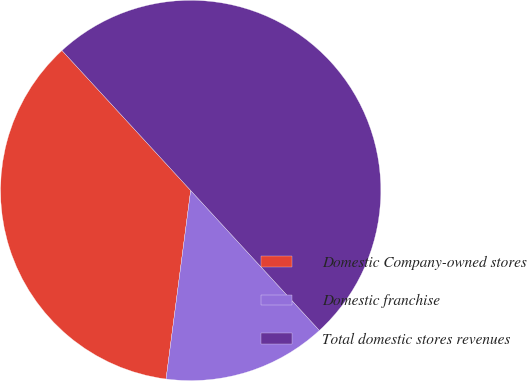Convert chart to OTSL. <chart><loc_0><loc_0><loc_500><loc_500><pie_chart><fcel>Domestic Company-owned stores<fcel>Domestic franchise<fcel>Total domestic stores revenues<nl><fcel>36.1%<fcel>13.9%<fcel>50.0%<nl></chart> 